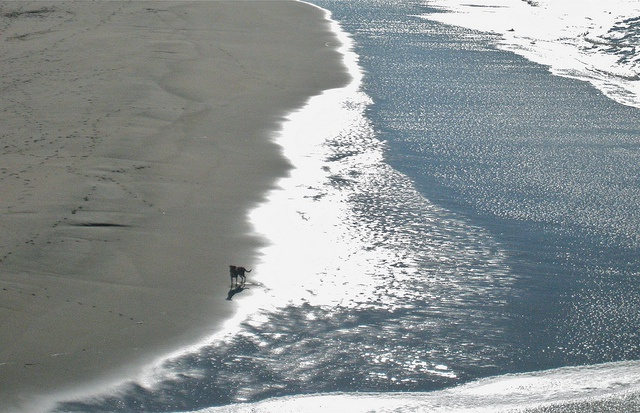Describe the objects in this image and their specific colors. I can see a dog in gray, black, darkgray, and purple tones in this image. 